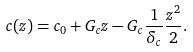Convert formula to latex. <formula><loc_0><loc_0><loc_500><loc_500>c ( z ) = c _ { 0 } + G _ { c } z - G _ { c } \frac { 1 } { \delta _ { c } } \frac { z ^ { 2 } } { 2 } .</formula> 